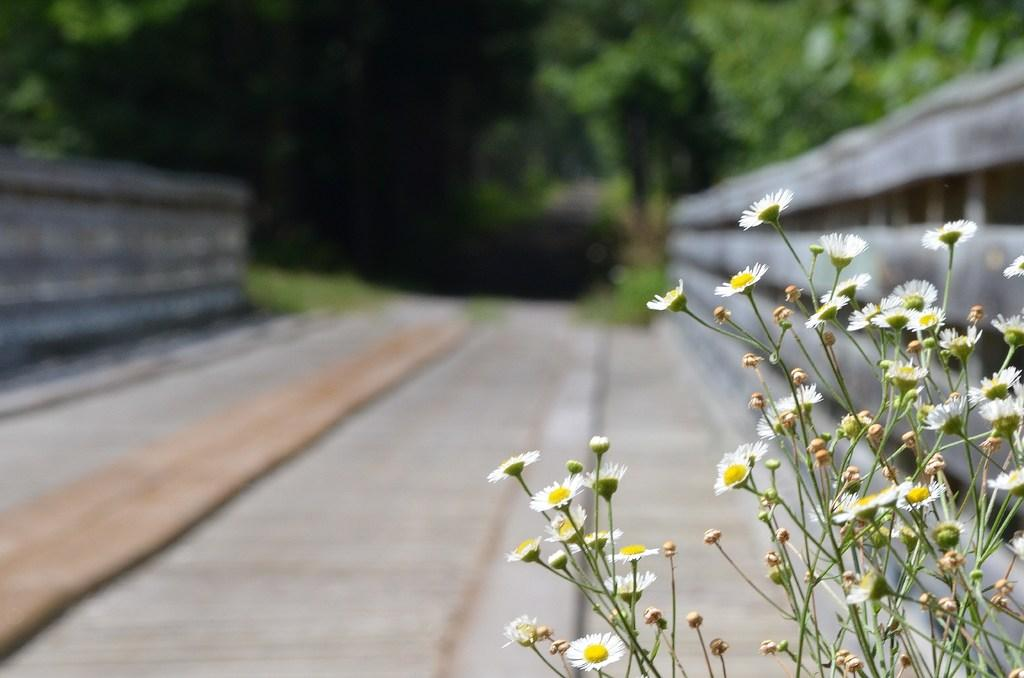What type of flowers can be seen on the right side of the image? There are white flowers on the right side of the image. What is the main feature in the foreground of the image? There is a road in the image. What can be seen in the background of the image? There are trees visible in the background of the image. What kind of trouble is the memory having with the partner in the image? There is no mention of memory or a partner in the image, as it only features white flowers, a road, and trees in the background. 